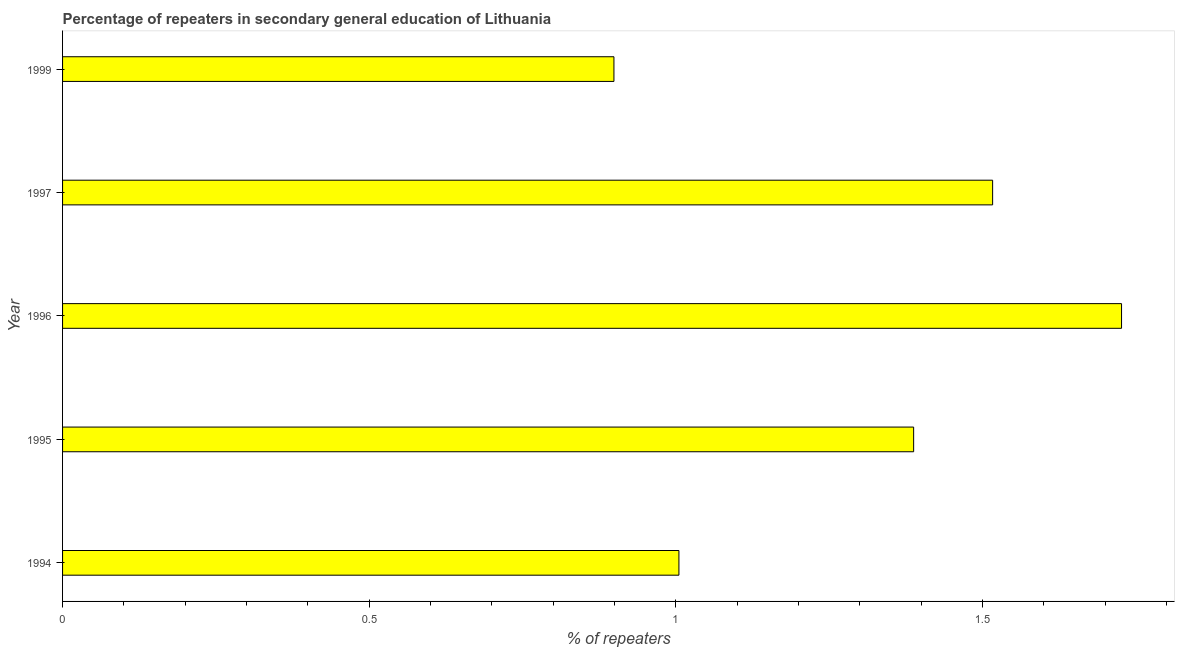Does the graph contain grids?
Give a very brief answer. No. What is the title of the graph?
Offer a terse response. Percentage of repeaters in secondary general education of Lithuania. What is the label or title of the X-axis?
Make the answer very short. % of repeaters. What is the label or title of the Y-axis?
Keep it short and to the point. Year. What is the percentage of repeaters in 1999?
Your answer should be very brief. 0.9. Across all years, what is the maximum percentage of repeaters?
Ensure brevity in your answer.  1.73. Across all years, what is the minimum percentage of repeaters?
Your answer should be very brief. 0.9. What is the sum of the percentage of repeaters?
Provide a succinct answer. 6.54. What is the difference between the percentage of repeaters in 1996 and 1997?
Your answer should be compact. 0.21. What is the average percentage of repeaters per year?
Give a very brief answer. 1.31. What is the median percentage of repeaters?
Give a very brief answer. 1.39. What is the ratio of the percentage of repeaters in 1994 to that in 1997?
Provide a short and direct response. 0.66. Is the difference between the percentage of repeaters in 1995 and 1996 greater than the difference between any two years?
Provide a succinct answer. No. What is the difference between the highest and the second highest percentage of repeaters?
Your answer should be compact. 0.21. What is the difference between the highest and the lowest percentage of repeaters?
Offer a terse response. 0.83. In how many years, is the percentage of repeaters greater than the average percentage of repeaters taken over all years?
Your response must be concise. 3. How many bars are there?
Offer a very short reply. 5. Are the values on the major ticks of X-axis written in scientific E-notation?
Your response must be concise. No. What is the % of repeaters of 1994?
Your response must be concise. 1.01. What is the % of repeaters of 1995?
Ensure brevity in your answer.  1.39. What is the % of repeaters of 1996?
Keep it short and to the point. 1.73. What is the % of repeaters in 1997?
Offer a terse response. 1.52. What is the % of repeaters of 1999?
Offer a terse response. 0.9. What is the difference between the % of repeaters in 1994 and 1995?
Offer a very short reply. -0.38. What is the difference between the % of repeaters in 1994 and 1996?
Your response must be concise. -0.72. What is the difference between the % of repeaters in 1994 and 1997?
Provide a succinct answer. -0.51. What is the difference between the % of repeaters in 1994 and 1999?
Your answer should be very brief. 0.11. What is the difference between the % of repeaters in 1995 and 1996?
Your response must be concise. -0.34. What is the difference between the % of repeaters in 1995 and 1997?
Your answer should be compact. -0.13. What is the difference between the % of repeaters in 1995 and 1999?
Offer a very short reply. 0.49. What is the difference between the % of repeaters in 1996 and 1997?
Provide a succinct answer. 0.21. What is the difference between the % of repeaters in 1996 and 1999?
Offer a very short reply. 0.83. What is the difference between the % of repeaters in 1997 and 1999?
Ensure brevity in your answer.  0.62. What is the ratio of the % of repeaters in 1994 to that in 1995?
Ensure brevity in your answer.  0.72. What is the ratio of the % of repeaters in 1994 to that in 1996?
Your response must be concise. 0.58. What is the ratio of the % of repeaters in 1994 to that in 1997?
Keep it short and to the point. 0.66. What is the ratio of the % of repeaters in 1994 to that in 1999?
Offer a terse response. 1.12. What is the ratio of the % of repeaters in 1995 to that in 1996?
Make the answer very short. 0.8. What is the ratio of the % of repeaters in 1995 to that in 1997?
Provide a succinct answer. 0.92. What is the ratio of the % of repeaters in 1995 to that in 1999?
Make the answer very short. 1.54. What is the ratio of the % of repeaters in 1996 to that in 1997?
Your answer should be compact. 1.14. What is the ratio of the % of repeaters in 1996 to that in 1999?
Provide a succinct answer. 1.92. What is the ratio of the % of repeaters in 1997 to that in 1999?
Keep it short and to the point. 1.69. 